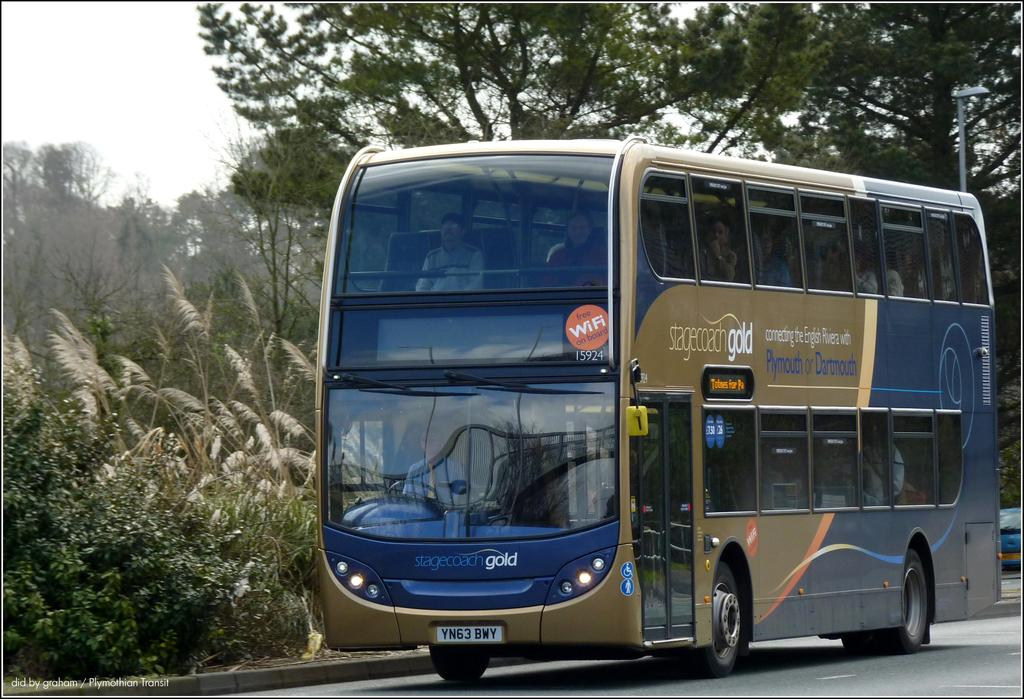What type of vehicle is in the image? There is a Double Decker bus in the image. Where is the bus located? The bus is on the road. What can be seen in the image besides the bus? There are trees visible in the image. What is visible in the background of the image? The sky is visible in the background of the image. How many cans of paint are needed to cover the distance between the bus and the trees in the image? There is no information about cans of paint or the distance between the bus and the trees in the image, so this question cannot be answered definitively. 